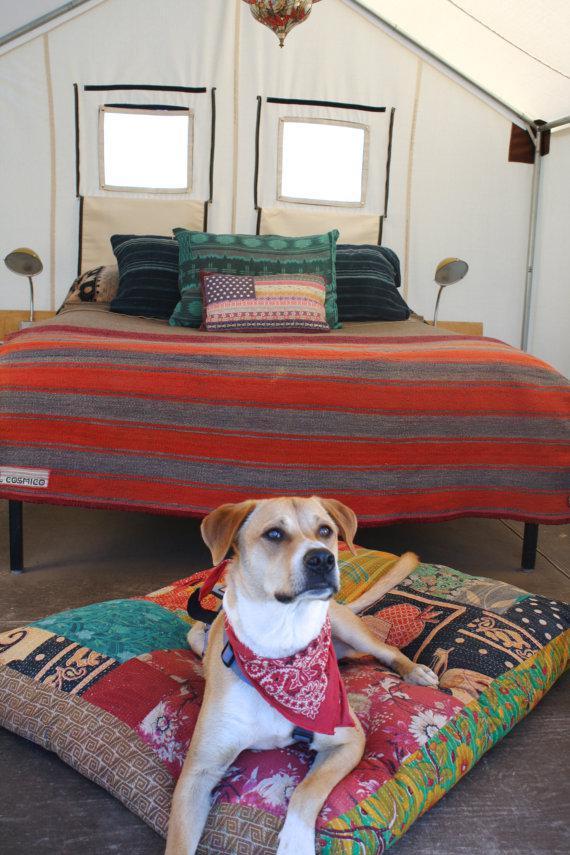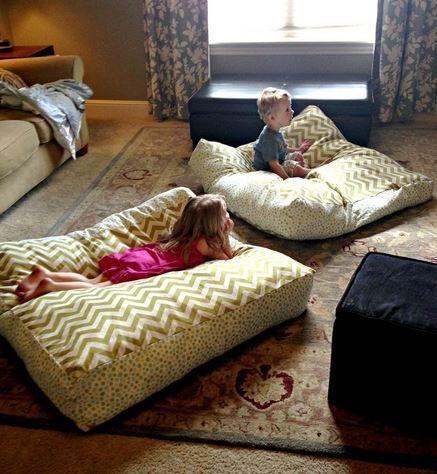The first image is the image on the left, the second image is the image on the right. Examine the images to the left and right. Is the description "The left image includes two people on some type of cushioned surface, and the right image features at least one little girl lying on her stomach on a mat consisting of several pillow sections." accurate? Answer yes or no. No. The first image is the image on the left, the second image is the image on the right. For the images shown, is this caption "The right image contains two children." true? Answer yes or no. Yes. 